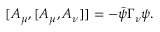<formula> <loc_0><loc_0><loc_500><loc_500>[ A _ { \mu } , [ A _ { \mu } , A _ { \nu } ] ] = - \bar { \psi } \Gamma _ { \nu } \psi .</formula> 